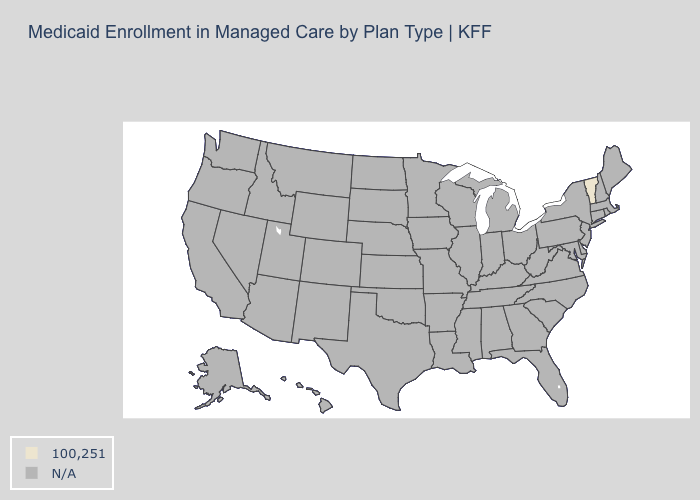What is the value of Iowa?
Be succinct. N/A. What is the value of New Hampshire?
Keep it brief. N/A. Does the first symbol in the legend represent the smallest category?
Give a very brief answer. No. Is the legend a continuous bar?
Write a very short answer. No. What is the highest value in the USA?
Be succinct. 100,251. Which states have the highest value in the USA?
Write a very short answer. Vermont. Does the first symbol in the legend represent the smallest category?
Short answer required. No. Does the map have missing data?
Be succinct. Yes. Which states hav the highest value in the Northeast?
Be succinct. Vermont. Name the states that have a value in the range N/A?
Short answer required. Alabama, Alaska, Arizona, Arkansas, California, Colorado, Connecticut, Delaware, Florida, Georgia, Hawaii, Idaho, Illinois, Indiana, Iowa, Kansas, Kentucky, Louisiana, Maine, Maryland, Massachusetts, Michigan, Minnesota, Mississippi, Missouri, Montana, Nebraska, Nevada, New Hampshire, New Jersey, New Mexico, New York, North Carolina, North Dakota, Ohio, Oklahoma, Oregon, Pennsylvania, Rhode Island, South Carolina, South Dakota, Tennessee, Texas, Utah, Virginia, Washington, West Virginia, Wisconsin, Wyoming. Is the legend a continuous bar?
Concise answer only. No. 